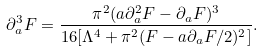<formula> <loc_0><loc_0><loc_500><loc_500>\partial _ { a } ^ { 3 } F = \frac { \pi ^ { 2 } ( a \partial _ { a } ^ { 2 } F - \partial _ { a } F ) ^ { 3 } } { 1 6 [ \Lambda ^ { 4 } + \pi ^ { 2 } ( F - a \partial _ { a } F / 2 ) ^ { 2 } ] } .</formula> 